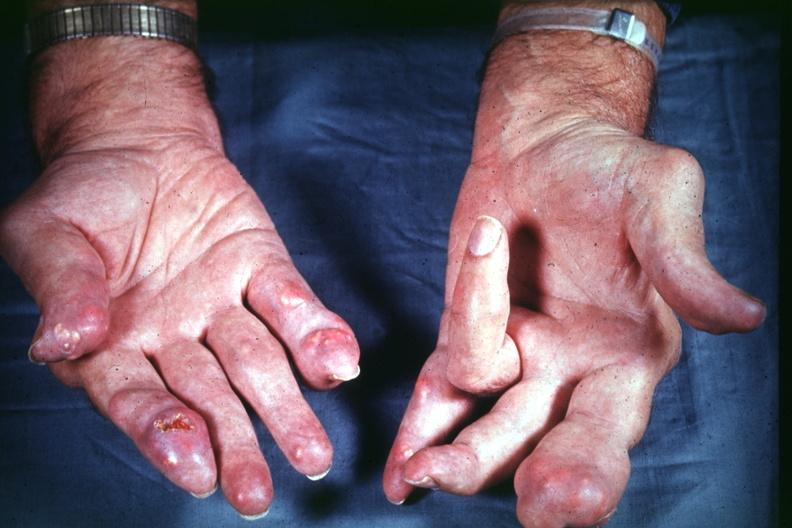what are present?
Answer the question using a single word or phrase. Extremities 